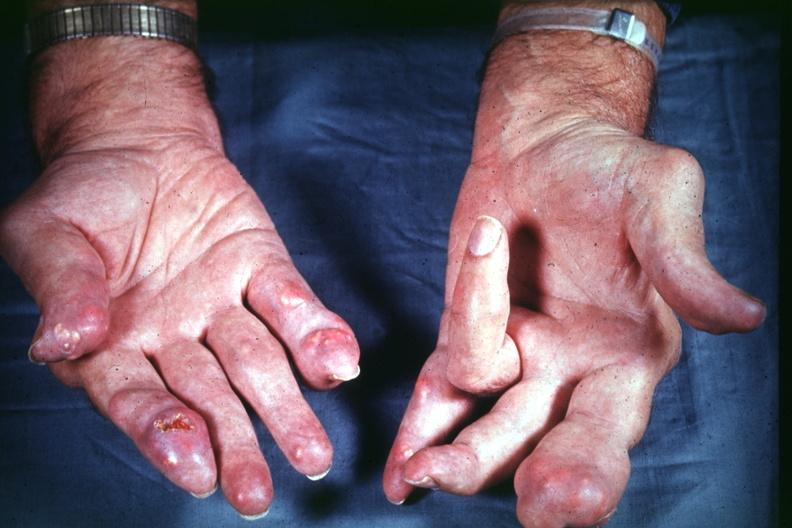what are present?
Answer the question using a single word or phrase. Extremities 